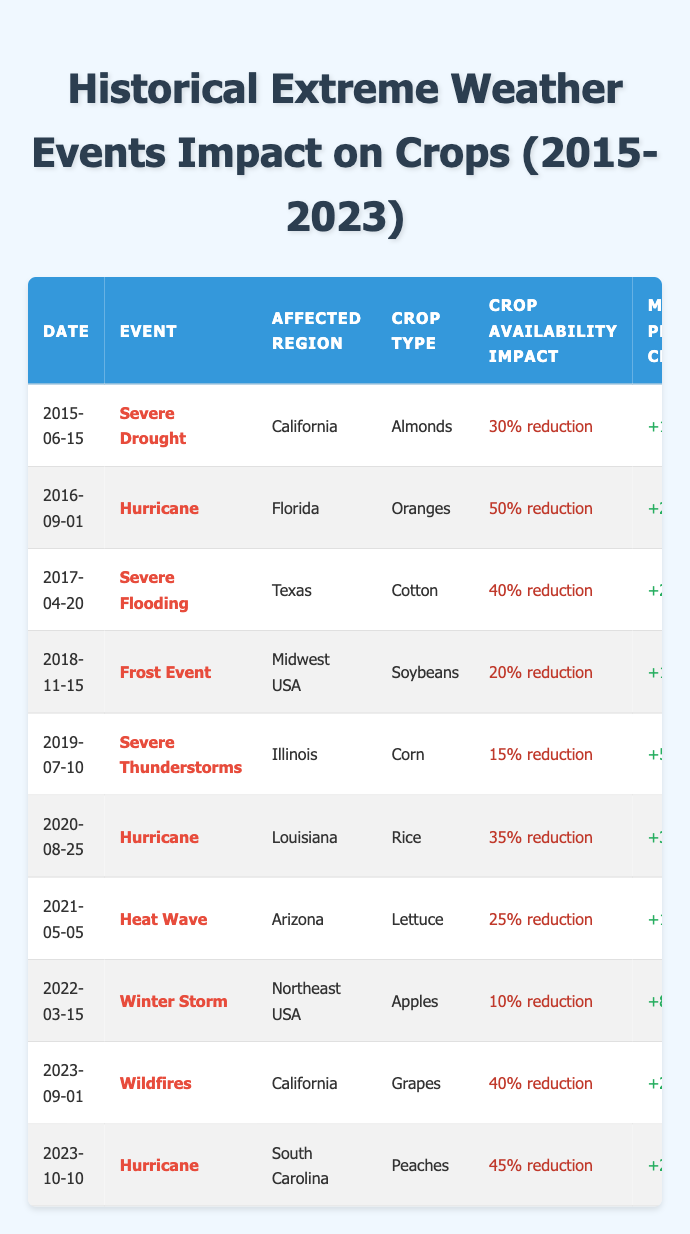What extreme weather event affected the crop availability of Oranges in Florida? The table shows that on 2016-09-01, a Hurricane impacted the crop availability of Oranges in Florida.
Answer: Hurricane What was the market price change for Cotton after the severe flooding in Texas? According to the table, following the severe flooding event on 2017-04-20, the market price change for Cotton was +20%.
Answer: +20% Which crop had the least reduction in availability due to an extreme weather event? By examining the crop availability impacts, the least reduction was 10% for Apples during a Winter Storm on 2022-03-15.
Answer: 10% for Apples Did any severe weather event in 2021 have a crop availability impact of more than 25%? The table indicates that the Heat Wave in Arizona affected Lettuce with a 25% reduction, and no other severe weather events in 2021 reported a higher impact. Therefore, the answer is no.
Answer: No How many crop availability impacts above 30% occurred in total, and what were the affected crops? The events with more than 30% reduction were the Hurricane in Florida (50% for Oranges), Severe Flooding in Texas (40% for Cotton), Hurricane in Louisiana (35% for Rice), Wildfires in California (40% for Grapes), and Hurricane in South Carolina (45% for Peaches). Summing them, there are 5 events above 30%.
Answer: 5 events: Oranges, Cotton, Rice, Grapes, Peaches What was the impact on crop availability for Almonds in California, and how much did the market price change? The table states that the Severe Drought on 2015-06-15 led to a 30% reduction in crop availability for Almonds, with a market price change of +15%.
Answer: 30% reduction, +15% What types of crops were affected by hurricanes between 2016 and 2023? The data shows that hurricanes impacted Oranges (2016), Rice (2020), and Peaches (2023). All resulted in significant reductions in crop availability, indicating hurricanes had varied impacts on these crops.
Answer: Oranges, Rice, Peaches Which extreme weather event in 2023 resulted in the highest crop availability impact? The table details the Hurricane in South Carolina on 2023-10-10 which caused a 45% reduction in Peaches, making it the highest impact event for that year.
Answer: Hurricane in South Carolina, 45% reduction How much did the market price change for crops affected by wildfires in California? The entry for Wildfires in California on 2023-09-01 shows a market price change of +20% for Grapes due to a 40% reduction in crop availability.
Answer: +20% Which year had the highest recorded impact on crop availability, and what was the event? The Hurricane in Florida on 2016-09-01 had the highest recorded impact of 50% reduction in availability for Oranges.
Answer: 2016, Hurricane in Florida, 50% reduction Was there any event that decreased crop availability and also significantly increased market prices? The table indicates that all events listed led to reductions in crop availability while simultaneously increasing market prices. Most notably, the Hurricane in Florida had a 50% reduction and increased market prices by +25%.
Answer: Yes, Hurricane in Florida 